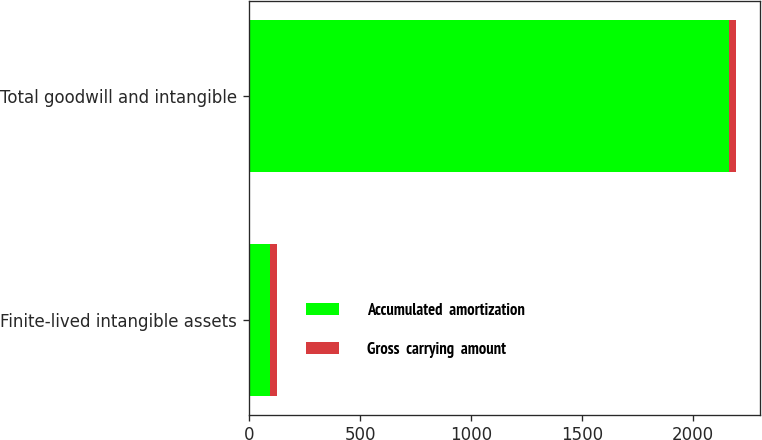<chart> <loc_0><loc_0><loc_500><loc_500><stacked_bar_chart><ecel><fcel>Finite-lived intangible assets<fcel>Total goodwill and intangible<nl><fcel>Accumulated  amortization<fcel>93.9<fcel>2162.1<nl><fcel>Gross  carrying  amount<fcel>30.2<fcel>30.2<nl></chart> 